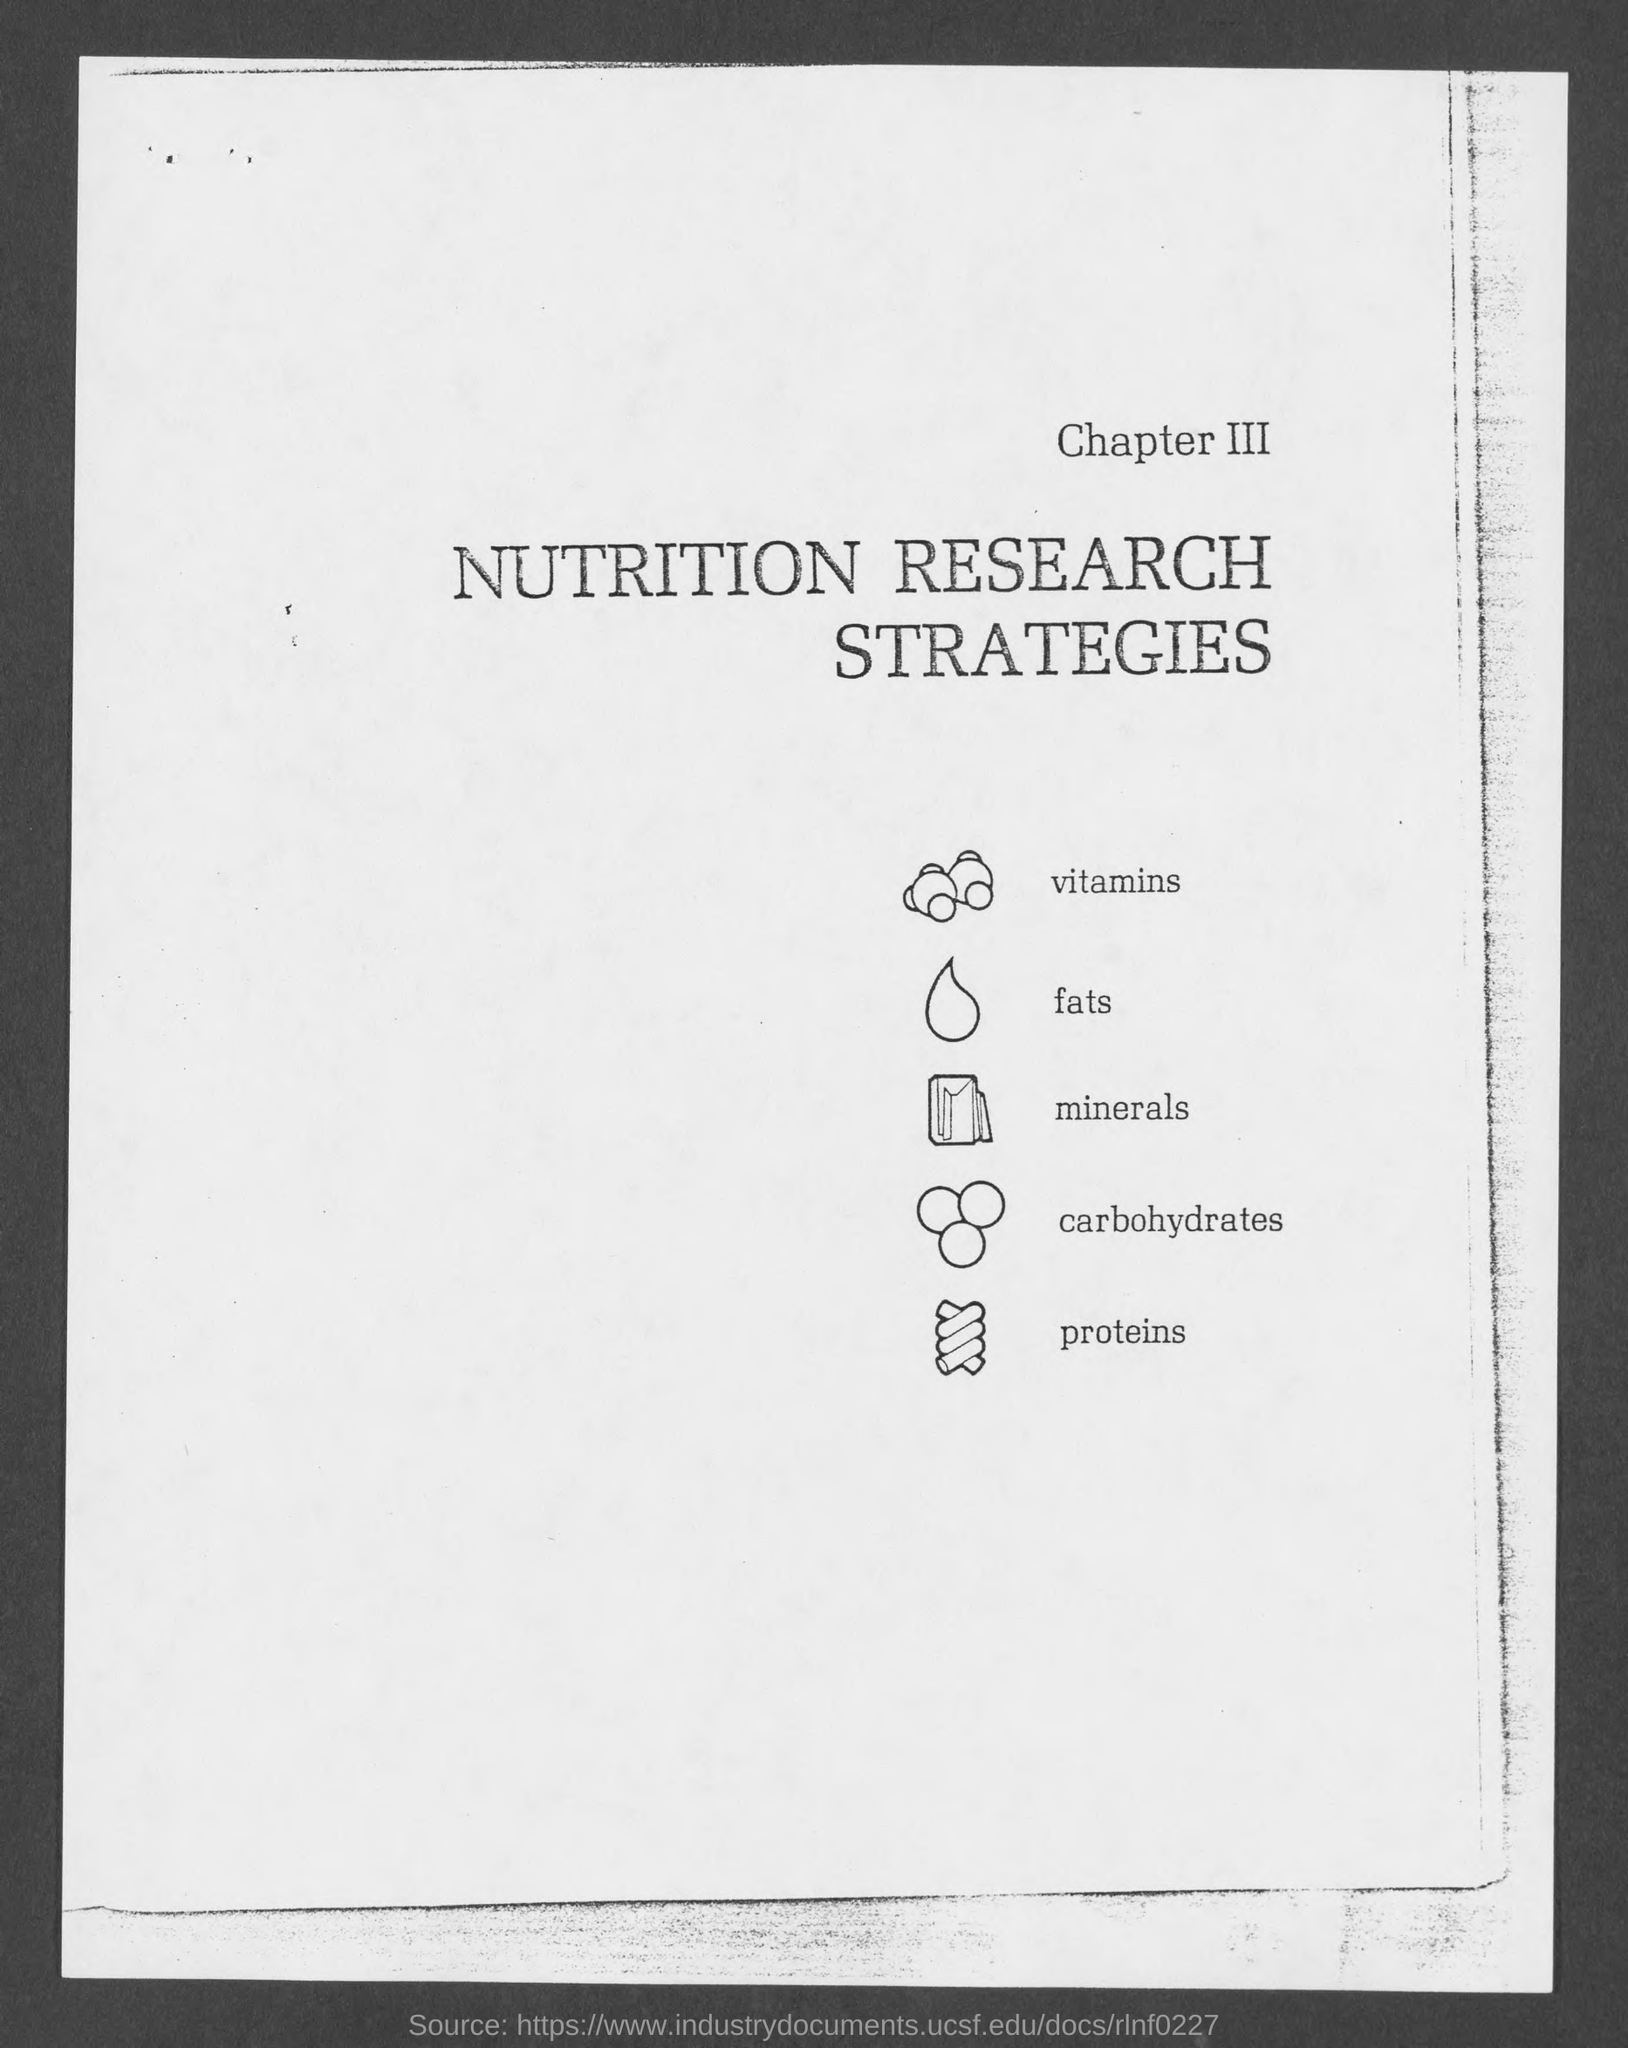What does Chapter III deal with?
Ensure brevity in your answer.  Nutrition research strategies. 